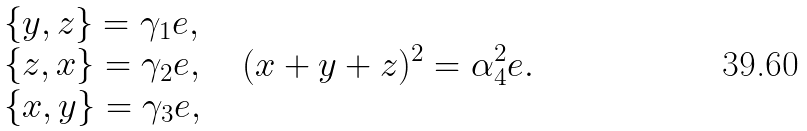<formula> <loc_0><loc_0><loc_500><loc_500>\begin{array} { l } \{ y , z \} = \gamma _ { 1 } e , \\ \{ z , x \} = \gamma _ { 2 } e , \\ \{ x , y \} = \gamma _ { 3 } e , \end{array} \quad ( x + y + z ) ^ { 2 } = \alpha _ { 4 } ^ { 2 } e .</formula> 